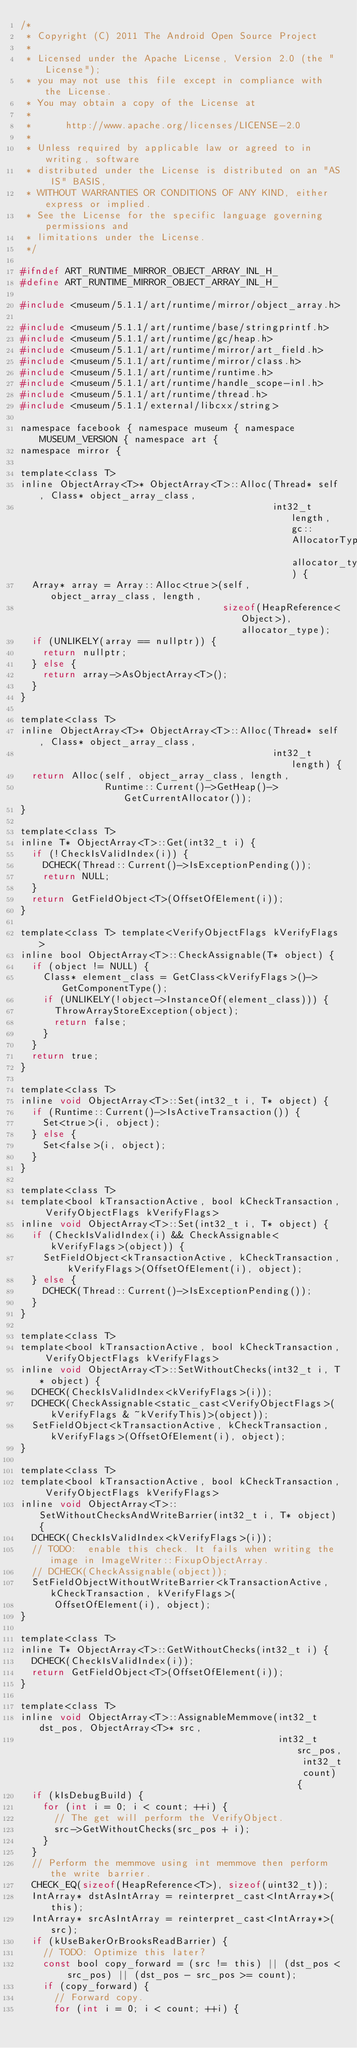<code> <loc_0><loc_0><loc_500><loc_500><_C_>/*
 * Copyright (C) 2011 The Android Open Source Project
 *
 * Licensed under the Apache License, Version 2.0 (the "License");
 * you may not use this file except in compliance with the License.
 * You may obtain a copy of the License at
 *
 *      http://www.apache.org/licenses/LICENSE-2.0
 *
 * Unless required by applicable law or agreed to in writing, software
 * distributed under the License is distributed on an "AS IS" BASIS,
 * WITHOUT WARRANTIES OR CONDITIONS OF ANY KIND, either express or implied.
 * See the License for the specific language governing permissions and
 * limitations under the License.
 */

#ifndef ART_RUNTIME_MIRROR_OBJECT_ARRAY_INL_H_
#define ART_RUNTIME_MIRROR_OBJECT_ARRAY_INL_H_

#include <museum/5.1.1/art/runtime/mirror/object_array.h>

#include <museum/5.1.1/art/runtime/base/stringprintf.h>
#include <museum/5.1.1/art/runtime/gc/heap.h>
#include <museum/5.1.1/art/runtime/mirror/art_field.h>
#include <museum/5.1.1/art/runtime/mirror/class.h>
#include <museum/5.1.1/art/runtime/runtime.h>
#include <museum/5.1.1/art/runtime/handle_scope-inl.h>
#include <museum/5.1.1/art/runtime/thread.h>
#include <museum/5.1.1/external/libcxx/string>

namespace facebook { namespace museum { namespace MUSEUM_VERSION { namespace art {
namespace mirror {

template<class T>
inline ObjectArray<T>* ObjectArray<T>::Alloc(Thread* self, Class* object_array_class,
                                             int32_t length, gc::AllocatorType allocator_type) {
  Array* array = Array::Alloc<true>(self, object_array_class, length,
                                    sizeof(HeapReference<Object>), allocator_type);
  if (UNLIKELY(array == nullptr)) {
    return nullptr;
  } else {
    return array->AsObjectArray<T>();
  }
}

template<class T>
inline ObjectArray<T>* ObjectArray<T>::Alloc(Thread* self, Class* object_array_class,
                                             int32_t length) {
  return Alloc(self, object_array_class, length,
               Runtime::Current()->GetHeap()->GetCurrentAllocator());
}

template<class T>
inline T* ObjectArray<T>::Get(int32_t i) {
  if (!CheckIsValidIndex(i)) {
    DCHECK(Thread::Current()->IsExceptionPending());
    return NULL;
  }
  return GetFieldObject<T>(OffsetOfElement(i));
}

template<class T> template<VerifyObjectFlags kVerifyFlags>
inline bool ObjectArray<T>::CheckAssignable(T* object) {
  if (object != NULL) {
    Class* element_class = GetClass<kVerifyFlags>()->GetComponentType();
    if (UNLIKELY(!object->InstanceOf(element_class))) {
      ThrowArrayStoreException(object);
      return false;
    }
  }
  return true;
}

template<class T>
inline void ObjectArray<T>::Set(int32_t i, T* object) {
  if (Runtime::Current()->IsActiveTransaction()) {
    Set<true>(i, object);
  } else {
    Set<false>(i, object);
  }
}

template<class T>
template<bool kTransactionActive, bool kCheckTransaction, VerifyObjectFlags kVerifyFlags>
inline void ObjectArray<T>::Set(int32_t i, T* object) {
  if (CheckIsValidIndex(i) && CheckAssignable<kVerifyFlags>(object)) {
    SetFieldObject<kTransactionActive, kCheckTransaction, kVerifyFlags>(OffsetOfElement(i), object);
  } else {
    DCHECK(Thread::Current()->IsExceptionPending());
  }
}

template<class T>
template<bool kTransactionActive, bool kCheckTransaction, VerifyObjectFlags kVerifyFlags>
inline void ObjectArray<T>::SetWithoutChecks(int32_t i, T* object) {
  DCHECK(CheckIsValidIndex<kVerifyFlags>(i));
  DCHECK(CheckAssignable<static_cast<VerifyObjectFlags>(kVerifyFlags & ~kVerifyThis)>(object));
  SetFieldObject<kTransactionActive, kCheckTransaction, kVerifyFlags>(OffsetOfElement(i), object);
}

template<class T>
template<bool kTransactionActive, bool kCheckTransaction, VerifyObjectFlags kVerifyFlags>
inline void ObjectArray<T>::SetWithoutChecksAndWriteBarrier(int32_t i, T* object) {
  DCHECK(CheckIsValidIndex<kVerifyFlags>(i));
  // TODO:  enable this check. It fails when writing the image in ImageWriter::FixupObjectArray.
  // DCHECK(CheckAssignable(object));
  SetFieldObjectWithoutWriteBarrier<kTransactionActive, kCheckTransaction, kVerifyFlags>(
      OffsetOfElement(i), object);
}

template<class T>
inline T* ObjectArray<T>::GetWithoutChecks(int32_t i) {
  DCHECK(CheckIsValidIndex(i));
  return GetFieldObject<T>(OffsetOfElement(i));
}

template<class T>
inline void ObjectArray<T>::AssignableMemmove(int32_t dst_pos, ObjectArray<T>* src,
                                              int32_t src_pos, int32_t count) {
  if (kIsDebugBuild) {
    for (int i = 0; i < count; ++i) {
      // The get will perform the VerifyObject.
      src->GetWithoutChecks(src_pos + i);
    }
  }
  // Perform the memmove using int memmove then perform the write barrier.
  CHECK_EQ(sizeof(HeapReference<T>), sizeof(uint32_t));
  IntArray* dstAsIntArray = reinterpret_cast<IntArray*>(this);
  IntArray* srcAsIntArray = reinterpret_cast<IntArray*>(src);
  if (kUseBakerOrBrooksReadBarrier) {
    // TODO: Optimize this later?
    const bool copy_forward = (src != this) || (dst_pos < src_pos) || (dst_pos - src_pos >= count);
    if (copy_forward) {
      // Forward copy.
      for (int i = 0; i < count; ++i) {</code> 